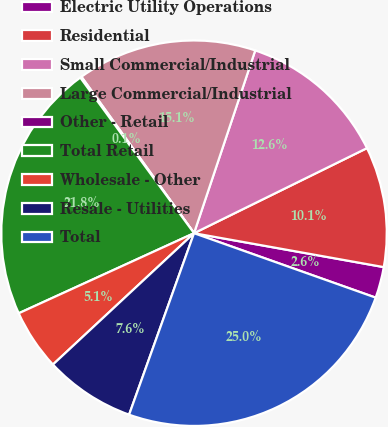Convert chart. <chart><loc_0><loc_0><loc_500><loc_500><pie_chart><fcel>Electric Utility Operations<fcel>Residential<fcel>Small Commercial/Industrial<fcel>Large Commercial/Industrial<fcel>Other - Retail<fcel>Total Retail<fcel>Wholesale - Other<fcel>Resale - Utilities<fcel>Total<nl><fcel>2.61%<fcel>10.09%<fcel>12.58%<fcel>15.07%<fcel>0.12%<fcel>21.77%<fcel>5.11%<fcel>7.6%<fcel>25.04%<nl></chart> 